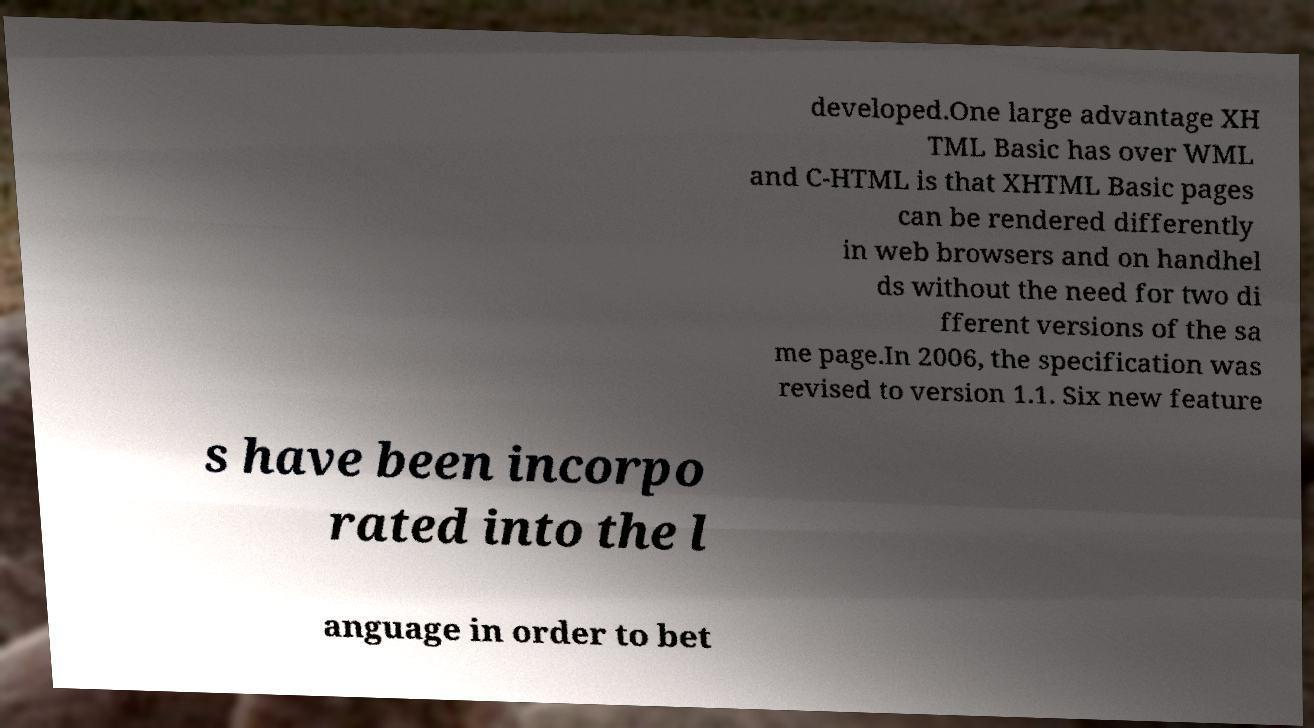For documentation purposes, I need the text within this image transcribed. Could you provide that? developed.One large advantage XH TML Basic has over WML and C-HTML is that XHTML Basic pages can be rendered differently in web browsers and on handhel ds without the need for two di fferent versions of the sa me page.In 2006, the specification was revised to version 1.1. Six new feature s have been incorpo rated into the l anguage in order to bet 